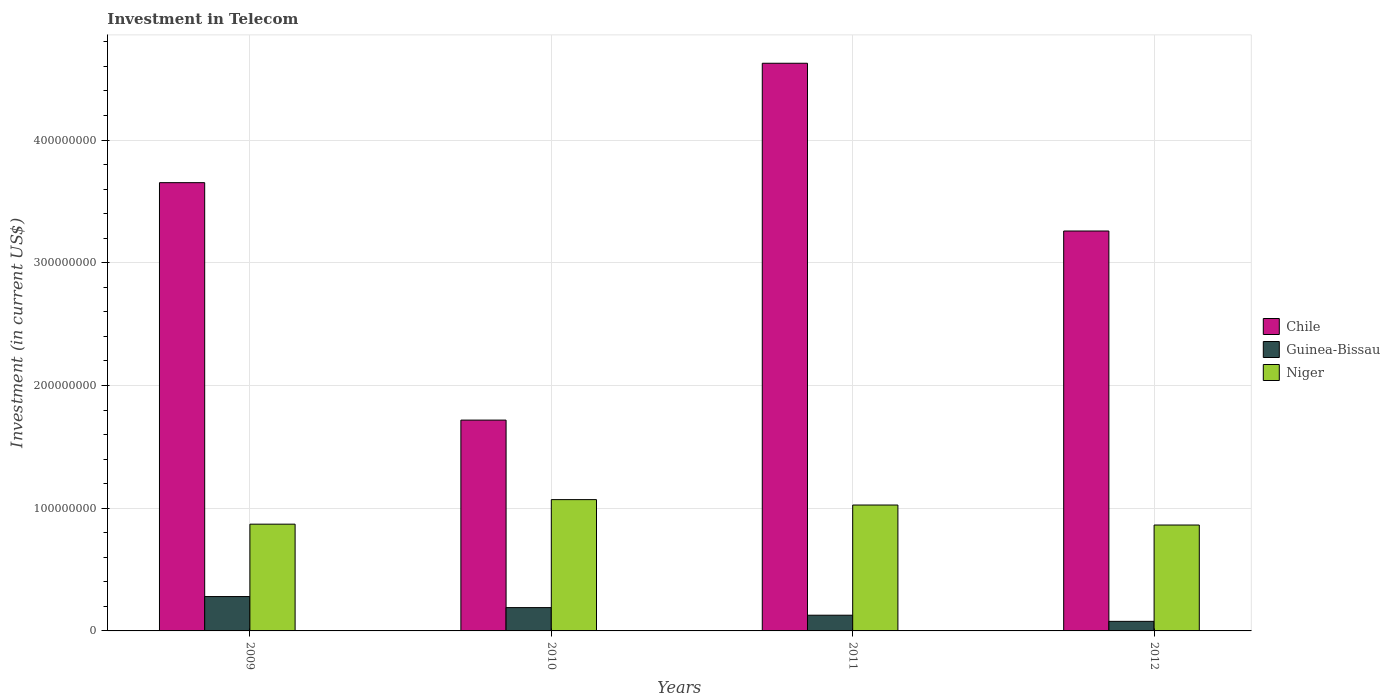How many groups of bars are there?
Keep it short and to the point. 4. Are the number of bars on each tick of the X-axis equal?
Offer a terse response. Yes. What is the label of the 2nd group of bars from the left?
Keep it short and to the point. 2010. In how many cases, is the number of bars for a given year not equal to the number of legend labels?
Your response must be concise. 0. What is the amount invested in telecom in Niger in 2010?
Make the answer very short. 1.07e+08. Across all years, what is the maximum amount invested in telecom in Guinea-Bissau?
Provide a short and direct response. 2.80e+07. Across all years, what is the minimum amount invested in telecom in Chile?
Ensure brevity in your answer.  1.72e+08. In which year was the amount invested in telecom in Chile maximum?
Provide a short and direct response. 2011. What is the total amount invested in telecom in Guinea-Bissau in the graph?
Keep it short and to the point. 6.76e+07. What is the difference between the amount invested in telecom in Guinea-Bissau in 2011 and that in 2012?
Keep it short and to the point. 5.00e+06. What is the difference between the amount invested in telecom in Chile in 2010 and the amount invested in telecom in Niger in 2012?
Offer a very short reply. 8.55e+07. What is the average amount invested in telecom in Chile per year?
Keep it short and to the point. 3.31e+08. In the year 2012, what is the difference between the amount invested in telecom in Niger and amount invested in telecom in Chile?
Offer a very short reply. -2.40e+08. In how many years, is the amount invested in telecom in Niger greater than 300000000 US$?
Your answer should be compact. 0. What is the ratio of the amount invested in telecom in Chile in 2009 to that in 2011?
Give a very brief answer. 0.79. Is the difference between the amount invested in telecom in Niger in 2009 and 2010 greater than the difference between the amount invested in telecom in Chile in 2009 and 2010?
Your answer should be compact. No. What is the difference between the highest and the second highest amount invested in telecom in Niger?
Keep it short and to the point. 4.40e+06. What is the difference between the highest and the lowest amount invested in telecom in Niger?
Give a very brief answer. 2.07e+07. Is the sum of the amount invested in telecom in Niger in 2010 and 2012 greater than the maximum amount invested in telecom in Guinea-Bissau across all years?
Keep it short and to the point. Yes. What does the 2nd bar from the left in 2012 represents?
Keep it short and to the point. Guinea-Bissau. What does the 1st bar from the right in 2009 represents?
Make the answer very short. Niger. How many bars are there?
Your answer should be compact. 12. How many years are there in the graph?
Provide a succinct answer. 4. Are the values on the major ticks of Y-axis written in scientific E-notation?
Offer a very short reply. No. How many legend labels are there?
Offer a very short reply. 3. How are the legend labels stacked?
Offer a terse response. Vertical. What is the title of the graph?
Offer a very short reply. Investment in Telecom. What is the label or title of the Y-axis?
Provide a succinct answer. Investment (in current US$). What is the Investment (in current US$) of Chile in 2009?
Provide a succinct answer. 3.65e+08. What is the Investment (in current US$) of Guinea-Bissau in 2009?
Offer a terse response. 2.80e+07. What is the Investment (in current US$) in Niger in 2009?
Your response must be concise. 8.70e+07. What is the Investment (in current US$) of Chile in 2010?
Offer a terse response. 1.72e+08. What is the Investment (in current US$) of Guinea-Bissau in 2010?
Give a very brief answer. 1.90e+07. What is the Investment (in current US$) of Niger in 2010?
Your answer should be very brief. 1.07e+08. What is the Investment (in current US$) in Chile in 2011?
Offer a very short reply. 4.63e+08. What is the Investment (in current US$) in Guinea-Bissau in 2011?
Keep it short and to the point. 1.28e+07. What is the Investment (in current US$) in Niger in 2011?
Provide a succinct answer. 1.03e+08. What is the Investment (in current US$) in Chile in 2012?
Provide a short and direct response. 3.26e+08. What is the Investment (in current US$) in Guinea-Bissau in 2012?
Offer a very short reply. 7.80e+06. What is the Investment (in current US$) in Niger in 2012?
Offer a very short reply. 8.63e+07. Across all years, what is the maximum Investment (in current US$) in Chile?
Your response must be concise. 4.63e+08. Across all years, what is the maximum Investment (in current US$) of Guinea-Bissau?
Make the answer very short. 2.80e+07. Across all years, what is the maximum Investment (in current US$) in Niger?
Your answer should be compact. 1.07e+08. Across all years, what is the minimum Investment (in current US$) in Chile?
Offer a very short reply. 1.72e+08. Across all years, what is the minimum Investment (in current US$) in Guinea-Bissau?
Provide a short and direct response. 7.80e+06. Across all years, what is the minimum Investment (in current US$) in Niger?
Ensure brevity in your answer.  8.63e+07. What is the total Investment (in current US$) in Chile in the graph?
Your answer should be very brief. 1.33e+09. What is the total Investment (in current US$) of Guinea-Bissau in the graph?
Provide a succinct answer. 6.76e+07. What is the total Investment (in current US$) in Niger in the graph?
Your response must be concise. 3.83e+08. What is the difference between the Investment (in current US$) in Chile in 2009 and that in 2010?
Provide a short and direct response. 1.94e+08. What is the difference between the Investment (in current US$) in Guinea-Bissau in 2009 and that in 2010?
Provide a succinct answer. 9.00e+06. What is the difference between the Investment (in current US$) of Niger in 2009 and that in 2010?
Ensure brevity in your answer.  -2.00e+07. What is the difference between the Investment (in current US$) in Chile in 2009 and that in 2011?
Offer a terse response. -9.73e+07. What is the difference between the Investment (in current US$) of Guinea-Bissau in 2009 and that in 2011?
Keep it short and to the point. 1.52e+07. What is the difference between the Investment (in current US$) in Niger in 2009 and that in 2011?
Your response must be concise. -1.56e+07. What is the difference between the Investment (in current US$) of Chile in 2009 and that in 2012?
Your response must be concise. 3.94e+07. What is the difference between the Investment (in current US$) in Guinea-Bissau in 2009 and that in 2012?
Make the answer very short. 2.02e+07. What is the difference between the Investment (in current US$) in Niger in 2009 and that in 2012?
Provide a short and direct response. 7.00e+05. What is the difference between the Investment (in current US$) of Chile in 2010 and that in 2011?
Your answer should be compact. -2.91e+08. What is the difference between the Investment (in current US$) in Guinea-Bissau in 2010 and that in 2011?
Provide a succinct answer. 6.20e+06. What is the difference between the Investment (in current US$) in Niger in 2010 and that in 2011?
Keep it short and to the point. 4.40e+06. What is the difference between the Investment (in current US$) of Chile in 2010 and that in 2012?
Make the answer very short. -1.54e+08. What is the difference between the Investment (in current US$) in Guinea-Bissau in 2010 and that in 2012?
Offer a terse response. 1.12e+07. What is the difference between the Investment (in current US$) in Niger in 2010 and that in 2012?
Provide a succinct answer. 2.07e+07. What is the difference between the Investment (in current US$) of Chile in 2011 and that in 2012?
Keep it short and to the point. 1.37e+08. What is the difference between the Investment (in current US$) in Niger in 2011 and that in 2012?
Provide a succinct answer. 1.63e+07. What is the difference between the Investment (in current US$) of Chile in 2009 and the Investment (in current US$) of Guinea-Bissau in 2010?
Ensure brevity in your answer.  3.46e+08. What is the difference between the Investment (in current US$) in Chile in 2009 and the Investment (in current US$) in Niger in 2010?
Make the answer very short. 2.58e+08. What is the difference between the Investment (in current US$) in Guinea-Bissau in 2009 and the Investment (in current US$) in Niger in 2010?
Give a very brief answer. -7.90e+07. What is the difference between the Investment (in current US$) of Chile in 2009 and the Investment (in current US$) of Guinea-Bissau in 2011?
Ensure brevity in your answer.  3.52e+08. What is the difference between the Investment (in current US$) of Chile in 2009 and the Investment (in current US$) of Niger in 2011?
Provide a succinct answer. 2.63e+08. What is the difference between the Investment (in current US$) in Guinea-Bissau in 2009 and the Investment (in current US$) in Niger in 2011?
Your answer should be compact. -7.46e+07. What is the difference between the Investment (in current US$) in Chile in 2009 and the Investment (in current US$) in Guinea-Bissau in 2012?
Provide a succinct answer. 3.58e+08. What is the difference between the Investment (in current US$) in Chile in 2009 and the Investment (in current US$) in Niger in 2012?
Provide a short and direct response. 2.79e+08. What is the difference between the Investment (in current US$) in Guinea-Bissau in 2009 and the Investment (in current US$) in Niger in 2012?
Your response must be concise. -5.83e+07. What is the difference between the Investment (in current US$) in Chile in 2010 and the Investment (in current US$) in Guinea-Bissau in 2011?
Your response must be concise. 1.59e+08. What is the difference between the Investment (in current US$) of Chile in 2010 and the Investment (in current US$) of Niger in 2011?
Keep it short and to the point. 6.92e+07. What is the difference between the Investment (in current US$) of Guinea-Bissau in 2010 and the Investment (in current US$) of Niger in 2011?
Provide a succinct answer. -8.36e+07. What is the difference between the Investment (in current US$) of Chile in 2010 and the Investment (in current US$) of Guinea-Bissau in 2012?
Offer a very short reply. 1.64e+08. What is the difference between the Investment (in current US$) of Chile in 2010 and the Investment (in current US$) of Niger in 2012?
Give a very brief answer. 8.55e+07. What is the difference between the Investment (in current US$) of Guinea-Bissau in 2010 and the Investment (in current US$) of Niger in 2012?
Make the answer very short. -6.73e+07. What is the difference between the Investment (in current US$) in Chile in 2011 and the Investment (in current US$) in Guinea-Bissau in 2012?
Make the answer very short. 4.55e+08. What is the difference between the Investment (in current US$) in Chile in 2011 and the Investment (in current US$) in Niger in 2012?
Offer a very short reply. 3.76e+08. What is the difference between the Investment (in current US$) in Guinea-Bissau in 2011 and the Investment (in current US$) in Niger in 2012?
Make the answer very short. -7.35e+07. What is the average Investment (in current US$) of Chile per year?
Offer a terse response. 3.31e+08. What is the average Investment (in current US$) of Guinea-Bissau per year?
Offer a terse response. 1.69e+07. What is the average Investment (in current US$) of Niger per year?
Keep it short and to the point. 9.57e+07. In the year 2009, what is the difference between the Investment (in current US$) in Chile and Investment (in current US$) in Guinea-Bissau?
Give a very brief answer. 3.37e+08. In the year 2009, what is the difference between the Investment (in current US$) in Chile and Investment (in current US$) in Niger?
Offer a very short reply. 2.78e+08. In the year 2009, what is the difference between the Investment (in current US$) of Guinea-Bissau and Investment (in current US$) of Niger?
Give a very brief answer. -5.90e+07. In the year 2010, what is the difference between the Investment (in current US$) in Chile and Investment (in current US$) in Guinea-Bissau?
Offer a terse response. 1.53e+08. In the year 2010, what is the difference between the Investment (in current US$) in Chile and Investment (in current US$) in Niger?
Give a very brief answer. 6.48e+07. In the year 2010, what is the difference between the Investment (in current US$) of Guinea-Bissau and Investment (in current US$) of Niger?
Your answer should be compact. -8.80e+07. In the year 2011, what is the difference between the Investment (in current US$) in Chile and Investment (in current US$) in Guinea-Bissau?
Give a very brief answer. 4.50e+08. In the year 2011, what is the difference between the Investment (in current US$) of Chile and Investment (in current US$) of Niger?
Your response must be concise. 3.60e+08. In the year 2011, what is the difference between the Investment (in current US$) in Guinea-Bissau and Investment (in current US$) in Niger?
Make the answer very short. -8.98e+07. In the year 2012, what is the difference between the Investment (in current US$) in Chile and Investment (in current US$) in Guinea-Bissau?
Your response must be concise. 3.18e+08. In the year 2012, what is the difference between the Investment (in current US$) of Chile and Investment (in current US$) of Niger?
Your response must be concise. 2.40e+08. In the year 2012, what is the difference between the Investment (in current US$) of Guinea-Bissau and Investment (in current US$) of Niger?
Give a very brief answer. -7.85e+07. What is the ratio of the Investment (in current US$) of Chile in 2009 to that in 2010?
Ensure brevity in your answer.  2.13. What is the ratio of the Investment (in current US$) in Guinea-Bissau in 2009 to that in 2010?
Give a very brief answer. 1.47. What is the ratio of the Investment (in current US$) of Niger in 2009 to that in 2010?
Ensure brevity in your answer.  0.81. What is the ratio of the Investment (in current US$) of Chile in 2009 to that in 2011?
Provide a succinct answer. 0.79. What is the ratio of the Investment (in current US$) of Guinea-Bissau in 2009 to that in 2011?
Keep it short and to the point. 2.19. What is the ratio of the Investment (in current US$) of Niger in 2009 to that in 2011?
Your response must be concise. 0.85. What is the ratio of the Investment (in current US$) in Chile in 2009 to that in 2012?
Offer a very short reply. 1.12. What is the ratio of the Investment (in current US$) of Guinea-Bissau in 2009 to that in 2012?
Provide a short and direct response. 3.59. What is the ratio of the Investment (in current US$) in Chile in 2010 to that in 2011?
Offer a terse response. 0.37. What is the ratio of the Investment (in current US$) in Guinea-Bissau in 2010 to that in 2011?
Your response must be concise. 1.48. What is the ratio of the Investment (in current US$) of Niger in 2010 to that in 2011?
Offer a terse response. 1.04. What is the ratio of the Investment (in current US$) in Chile in 2010 to that in 2012?
Offer a very short reply. 0.53. What is the ratio of the Investment (in current US$) in Guinea-Bissau in 2010 to that in 2012?
Your answer should be very brief. 2.44. What is the ratio of the Investment (in current US$) of Niger in 2010 to that in 2012?
Give a very brief answer. 1.24. What is the ratio of the Investment (in current US$) in Chile in 2011 to that in 2012?
Your response must be concise. 1.42. What is the ratio of the Investment (in current US$) in Guinea-Bissau in 2011 to that in 2012?
Offer a terse response. 1.64. What is the ratio of the Investment (in current US$) of Niger in 2011 to that in 2012?
Your answer should be compact. 1.19. What is the difference between the highest and the second highest Investment (in current US$) of Chile?
Offer a terse response. 9.73e+07. What is the difference between the highest and the second highest Investment (in current US$) of Guinea-Bissau?
Give a very brief answer. 9.00e+06. What is the difference between the highest and the second highest Investment (in current US$) of Niger?
Your response must be concise. 4.40e+06. What is the difference between the highest and the lowest Investment (in current US$) in Chile?
Give a very brief answer. 2.91e+08. What is the difference between the highest and the lowest Investment (in current US$) in Guinea-Bissau?
Your response must be concise. 2.02e+07. What is the difference between the highest and the lowest Investment (in current US$) in Niger?
Ensure brevity in your answer.  2.07e+07. 